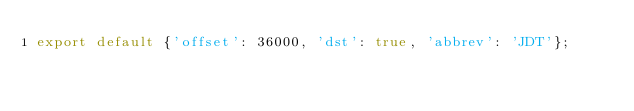<code> <loc_0><loc_0><loc_500><loc_500><_JavaScript_>export default {'offset': 36000, 'dst': true, 'abbrev': 'JDT'};
</code> 